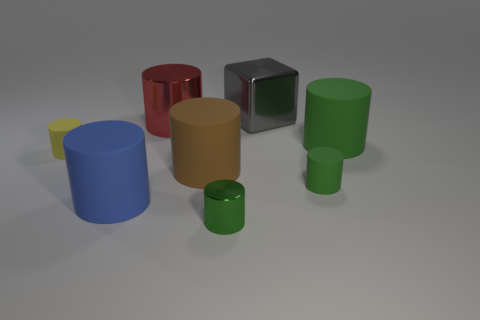Does the small matte cylinder to the right of the red metallic cylinder have the same color as the small cylinder in front of the large blue object?
Keep it short and to the point. Yes. What number of other things are there of the same material as the large gray block
Offer a very short reply. 2. Is the small cylinder that is left of the big brown thing made of the same material as the gray block?
Your response must be concise. No. There is a red thing that is the same shape as the big green object; what material is it?
Your answer should be very brief. Metal. What is the material of the other small cylinder that is the same color as the small metal cylinder?
Give a very brief answer. Rubber. There is a small matte thing that is right of the big gray shiny thing; is its color the same as the small shiny thing?
Ensure brevity in your answer.  Yes. What is the large gray thing made of?
Keep it short and to the point. Metal. What material is the gray thing that is the same size as the red metal object?
Your response must be concise. Metal. How many matte things are large blue cylinders or red cylinders?
Give a very brief answer. 1. What number of rubber cylinders are the same color as the tiny shiny cylinder?
Offer a very short reply. 2. 